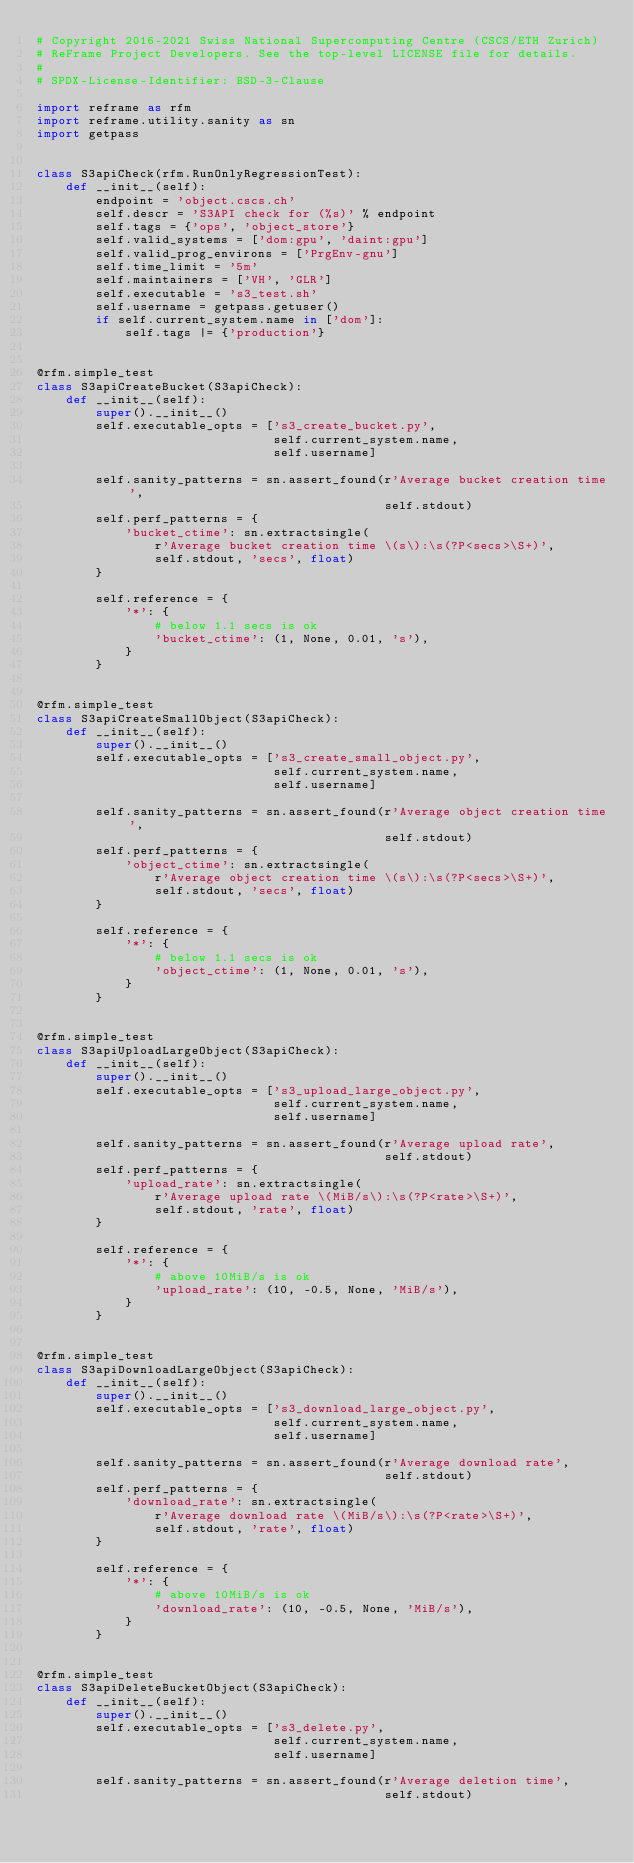<code> <loc_0><loc_0><loc_500><loc_500><_Python_># Copyright 2016-2021 Swiss National Supercomputing Centre (CSCS/ETH Zurich)
# ReFrame Project Developers. See the top-level LICENSE file for details.
#
# SPDX-License-Identifier: BSD-3-Clause

import reframe as rfm
import reframe.utility.sanity as sn
import getpass


class S3apiCheck(rfm.RunOnlyRegressionTest):
    def __init__(self):
        endpoint = 'object.cscs.ch'
        self.descr = 'S3API check for (%s)' % endpoint
        self.tags = {'ops', 'object_store'}
        self.valid_systems = ['dom:gpu', 'daint:gpu']
        self.valid_prog_environs = ['PrgEnv-gnu']
        self.time_limit = '5m'
        self.maintainers = ['VH', 'GLR']
        self.executable = 's3_test.sh'
        self.username = getpass.getuser()
        if self.current_system.name in ['dom']:
            self.tags |= {'production'}


@rfm.simple_test
class S3apiCreateBucket(S3apiCheck):
    def __init__(self):
        super().__init__()
        self.executable_opts = ['s3_create_bucket.py',
                                self.current_system.name,
                                self.username]

        self.sanity_patterns = sn.assert_found(r'Average bucket creation time',
                                               self.stdout)
        self.perf_patterns = {
            'bucket_ctime': sn.extractsingle(
                r'Average bucket creation time \(s\):\s(?P<secs>\S+)',
                self.stdout, 'secs', float)
        }

        self.reference = {
            '*': {
                # below 1.1 secs is ok
                'bucket_ctime': (1, None, 0.01, 's'),
            }
        }


@rfm.simple_test
class S3apiCreateSmallObject(S3apiCheck):
    def __init__(self):
        super().__init__()
        self.executable_opts = ['s3_create_small_object.py',
                                self.current_system.name,
                                self.username]

        self.sanity_patterns = sn.assert_found(r'Average object creation time',
                                               self.stdout)
        self.perf_patterns = {
            'object_ctime': sn.extractsingle(
                r'Average object creation time \(s\):\s(?P<secs>\S+)',
                self.stdout, 'secs', float)
        }

        self.reference = {
            '*': {
                # below 1.1 secs is ok
                'object_ctime': (1, None, 0.01, 's'),
            }
        }


@rfm.simple_test
class S3apiUploadLargeObject(S3apiCheck):
    def __init__(self):
        super().__init__()
        self.executable_opts = ['s3_upload_large_object.py',
                                self.current_system.name,
                                self.username]

        self.sanity_patterns = sn.assert_found(r'Average upload rate',
                                               self.stdout)
        self.perf_patterns = {
            'upload_rate': sn.extractsingle(
                r'Average upload rate \(MiB/s\):\s(?P<rate>\S+)',
                self.stdout, 'rate', float)
        }

        self.reference = {
            '*': {
                # above 10MiB/s is ok
                'upload_rate': (10, -0.5, None, 'MiB/s'),
            }
        }


@rfm.simple_test
class S3apiDownloadLargeObject(S3apiCheck):
    def __init__(self):
        super().__init__()
        self.executable_opts = ['s3_download_large_object.py',
                                self.current_system.name,
                                self.username]

        self.sanity_patterns = sn.assert_found(r'Average download rate',
                                               self.stdout)
        self.perf_patterns = {
            'download_rate': sn.extractsingle(
                r'Average download rate \(MiB/s\):\s(?P<rate>\S+)',
                self.stdout, 'rate', float)
        }

        self.reference = {
            '*': {
                # above 10MiB/s is ok
                'download_rate': (10, -0.5, None, 'MiB/s'),
            }
        }


@rfm.simple_test
class S3apiDeleteBucketObject(S3apiCheck):
    def __init__(self):
        super().__init__()
        self.executable_opts = ['s3_delete.py',
                                self.current_system.name,
                                self.username]

        self.sanity_patterns = sn.assert_found(r'Average deletion time',
                                               self.stdout)</code> 